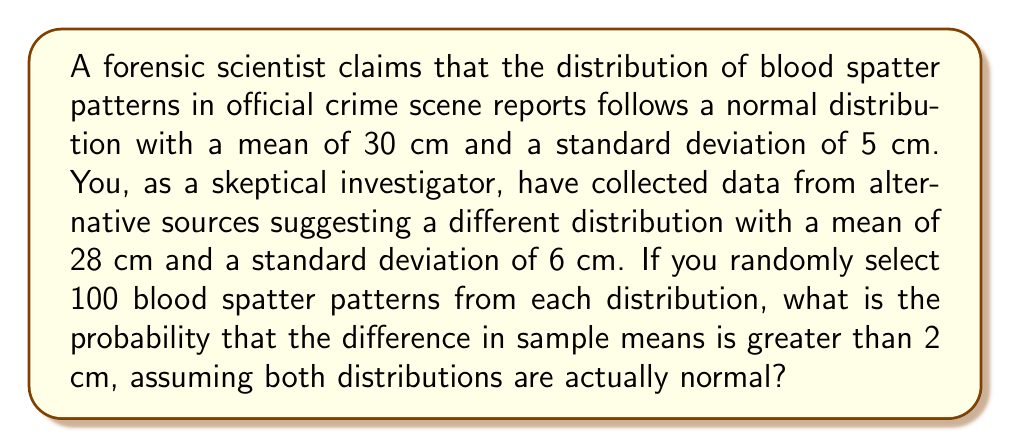Can you solve this math problem? Let's approach this step-by-step:

1) We have two distributions:
   Official: $X_1 \sim N(\mu_1 = 30, \sigma_1 = 5)$
   Alternative: $X_2 \sim N(\mu_2 = 28, \sigma_2 = 6)$

2) We're comparing the difference in sample means: $\bar{X_1} - \bar{X_2}$

3) The sampling distribution of the difference in means is also normal with:
   $\mu_{\bar{X_1} - \bar{X_2}} = \mu_1 - \mu_2 = 30 - 28 = 2$
   $\sigma_{\bar{X_1} - \bar{X_2}}^2 = \frac{\sigma_1^2}{n_1} + \frac{\sigma_2^2}{n_2} = \frac{5^2}{100} + \frac{6^2}{100} = 0.25 + 0.36 = 0.61$
   $\sigma_{\bar{X_1} - \bar{X_2}} = \sqrt{0.61} \approx 0.7810$

4) We want to find $P(\bar{X_1} - \bar{X_2} > 2)$

5) Standardizing:
   $Z = \frac{(\bar{X_1} - \bar{X_2}) - \mu_{\bar{X_1} - \bar{X_2}}}{\sigma_{\bar{X_1} - \bar{X_2}}} = \frac{2 - 2}{0.7810} = 0$

6) We need $P(Z > 0)$, which is 0.5 due to the symmetry of the standard normal distribution.
Answer: 0.5 